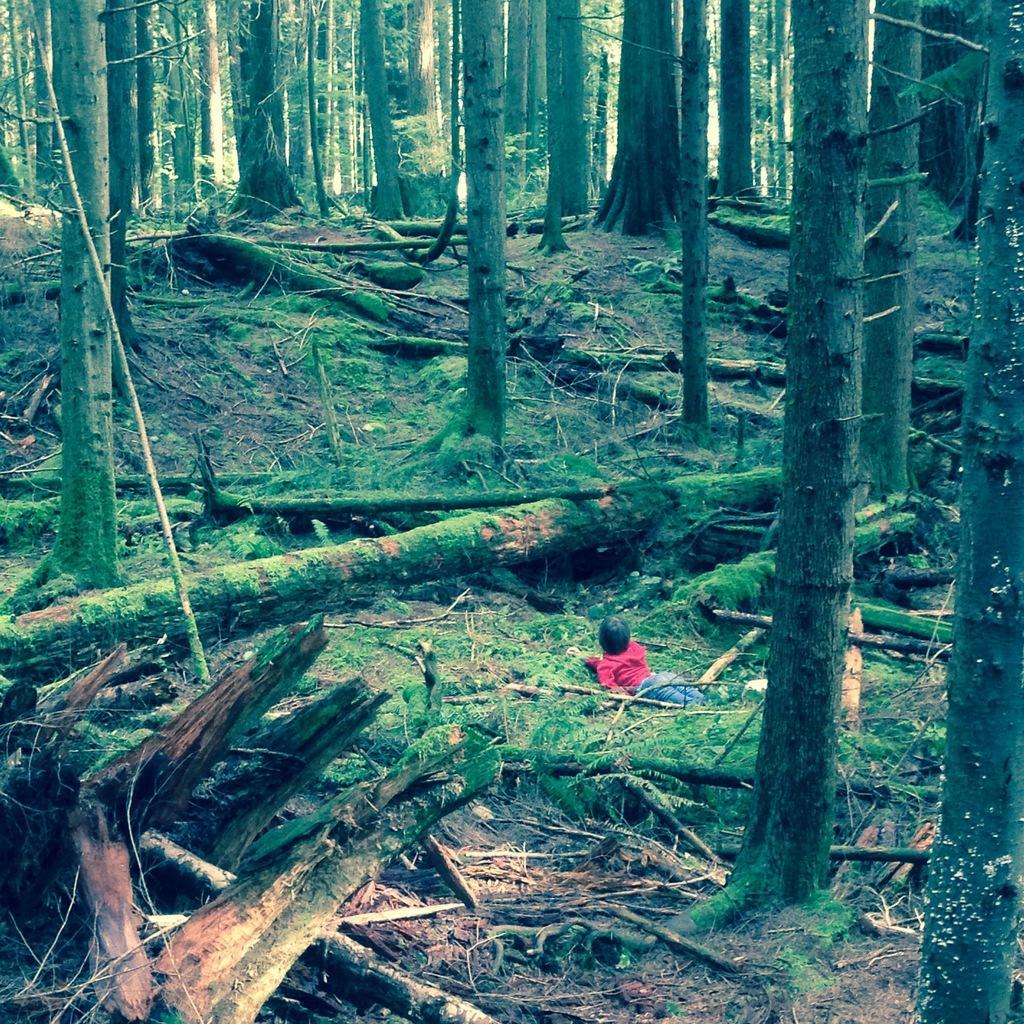Please provide a concise description of this image. This picture is clicked outside. On the right there is a person lying on the ground and we can see there are some objects lying on the ground and we can see the trunks of the trees and many other objects. In the background we can see the trees. 